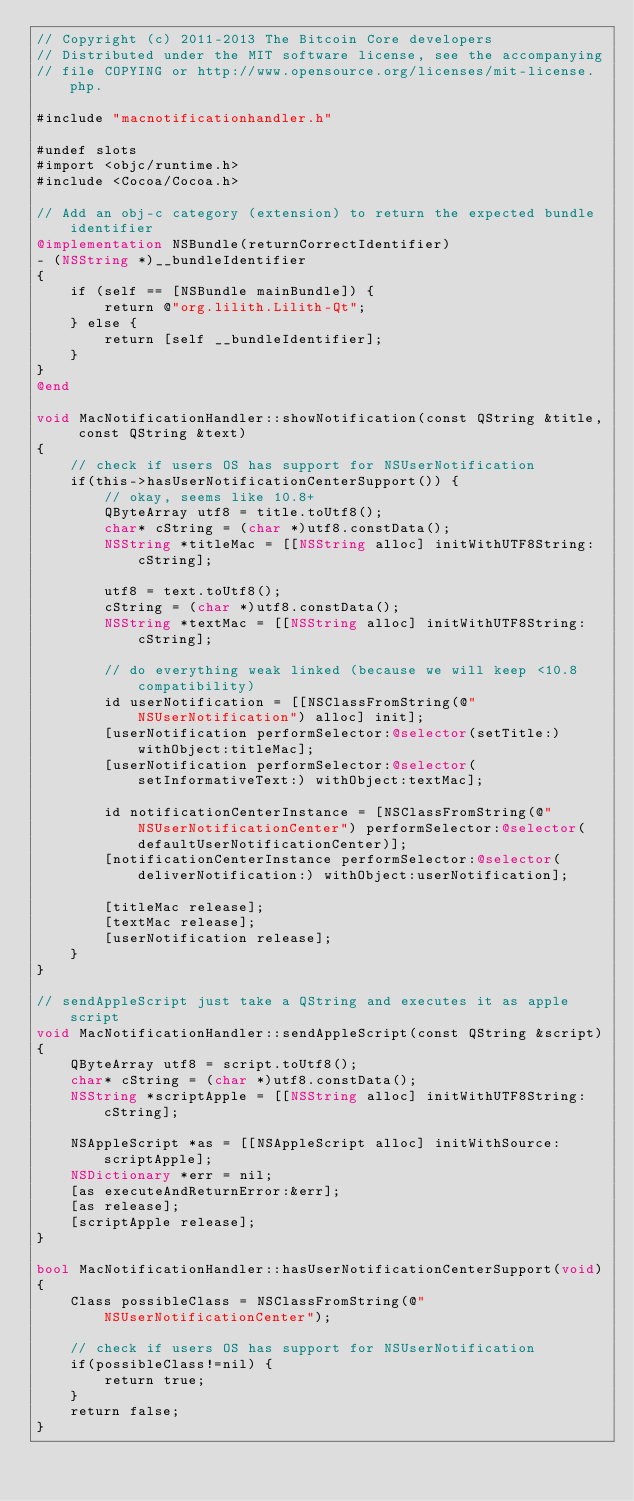Convert code to text. <code><loc_0><loc_0><loc_500><loc_500><_ObjectiveC_>// Copyright (c) 2011-2013 The Bitcoin Core developers
// Distributed under the MIT software license, see the accompanying
// file COPYING or http://www.opensource.org/licenses/mit-license.php.

#include "macnotificationhandler.h"

#undef slots
#import <objc/runtime.h>
#include <Cocoa/Cocoa.h>

// Add an obj-c category (extension) to return the expected bundle identifier
@implementation NSBundle(returnCorrectIdentifier)
- (NSString *)__bundleIdentifier
{
    if (self == [NSBundle mainBundle]) {
        return @"org.lilith.Lilith-Qt";
    } else {
        return [self __bundleIdentifier];
    }
}
@end

void MacNotificationHandler::showNotification(const QString &title, const QString &text)
{
    // check if users OS has support for NSUserNotification
    if(this->hasUserNotificationCenterSupport()) {
        // okay, seems like 10.8+
        QByteArray utf8 = title.toUtf8();
        char* cString = (char *)utf8.constData();
        NSString *titleMac = [[NSString alloc] initWithUTF8String:cString];

        utf8 = text.toUtf8();
        cString = (char *)utf8.constData();
        NSString *textMac = [[NSString alloc] initWithUTF8String:cString];

        // do everything weak linked (because we will keep <10.8 compatibility)
        id userNotification = [[NSClassFromString(@"NSUserNotification") alloc] init];
        [userNotification performSelector:@selector(setTitle:) withObject:titleMac];
        [userNotification performSelector:@selector(setInformativeText:) withObject:textMac];

        id notificationCenterInstance = [NSClassFromString(@"NSUserNotificationCenter") performSelector:@selector(defaultUserNotificationCenter)];
        [notificationCenterInstance performSelector:@selector(deliverNotification:) withObject:userNotification];

        [titleMac release];
        [textMac release];
        [userNotification release];
    }
}

// sendAppleScript just take a QString and executes it as apple script
void MacNotificationHandler::sendAppleScript(const QString &script)
{
    QByteArray utf8 = script.toUtf8();
    char* cString = (char *)utf8.constData();
    NSString *scriptApple = [[NSString alloc] initWithUTF8String:cString];

    NSAppleScript *as = [[NSAppleScript alloc] initWithSource:scriptApple];
    NSDictionary *err = nil;
    [as executeAndReturnError:&err];
    [as release];
    [scriptApple release];
}

bool MacNotificationHandler::hasUserNotificationCenterSupport(void)
{
    Class possibleClass = NSClassFromString(@"NSUserNotificationCenter");

    // check if users OS has support for NSUserNotification
    if(possibleClass!=nil) {
        return true;
    }
    return false;
}

</code> 